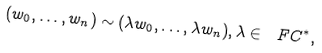Convert formula to latex. <formula><loc_0><loc_0><loc_500><loc_500>( w _ { 0 } , \dots , w _ { n } ) \sim ( \lambda w _ { 0 } , \dots , \lambda w _ { n } ) , \lambda \in \ F C ^ { * } ,</formula> 